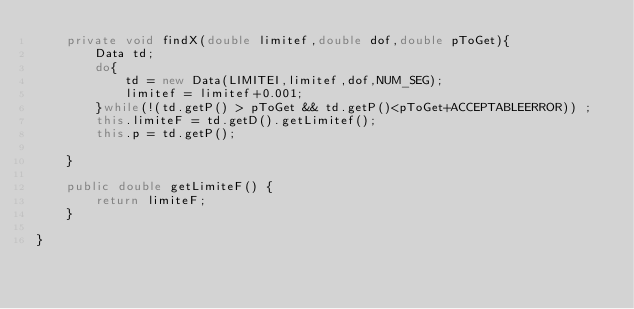Convert code to text. <code><loc_0><loc_0><loc_500><loc_500><_Java_>    private void findX(double limitef,double dof,double pToGet){
        Data td;
        do{                                             
            td = new Data(LIMITEI,limitef,dof,NUM_SEG);                            
            limitef = limitef+0.001;
        }while(!(td.getP() > pToGet && td.getP()<pToGet+ACCEPTABLEERROR)) ;
        this.limiteF = td.getD().getLimitef();
        this.p = td.getP();
        
    }
    
    public double getLimiteF() {
        return limiteF;
    }
    
}
</code> 